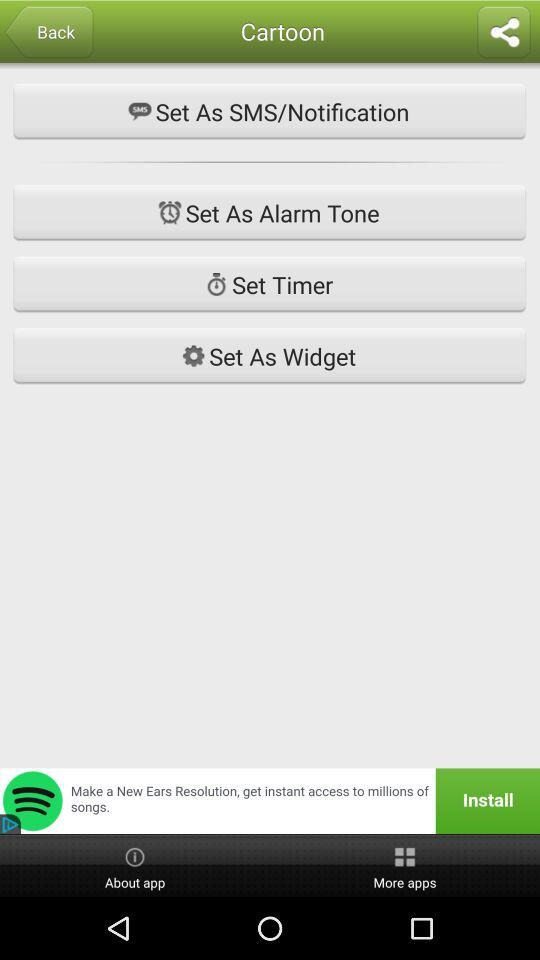What is the application name? The application name is "Cartoon". 